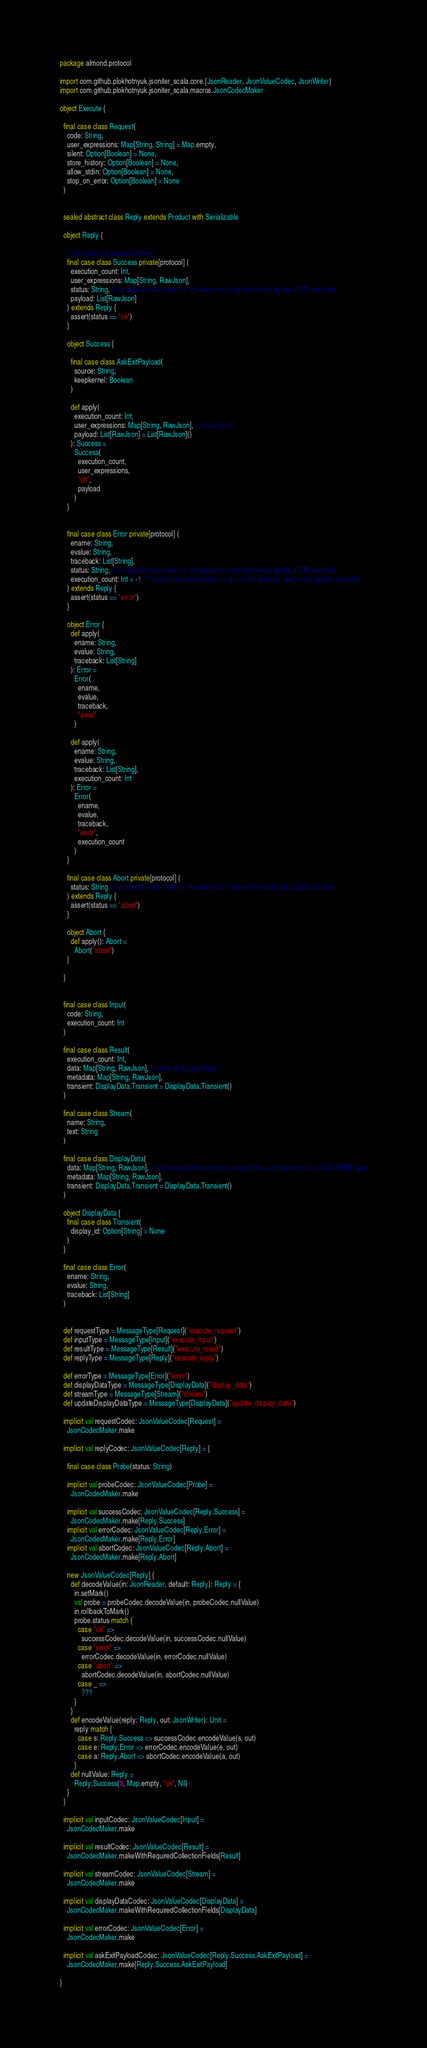<code> <loc_0><loc_0><loc_500><loc_500><_Scala_>package almond.protocol

import com.github.plokhotnyuk.jsoniter_scala.core.{JsonReader, JsonValueCodec, JsonWriter}
import com.github.plokhotnyuk.jsoniter_scala.macros.JsonCodecMaker

object Execute {

  final case class Request(
    code: String,
    user_expressions: Map[String, String] = Map.empty,
    silent: Option[Boolean] = None,
    store_history: Option[Boolean] = None,
    allow_stdin: Option[Boolean] = None,
    stop_on_error: Option[Boolean] = None
  )


  sealed abstract class Reply extends Product with Serializable

  object Reply {

    // payloads not supported here
    final case class Success private[protocol] (
      execution_count: Int,
      user_expressions: Map[String, RawJson],
      status: String, // no default value here for the value not to be swallowed by the JSON encoder
      payload: List[RawJson]
    ) extends Reply {
      assert(status == "ok")
    }

    object Success {

      final case class AskExitPayload(
        source: String,
        keepkernel: Boolean
      )

      def apply(
        execution_count: Int,
        user_expressions: Map[String, RawJson], // value type?
        payload: List[RawJson] = List[RawJson]()
      ): Success =
        Success(
          execution_count,
          user_expressions,
          "ok",
          payload
        )
    }


    final case class Error private[protocol] (
      ename: String,
      evalue: String,
      traceback: List[String],
      status: String, // no default value here for the value not to be swallowed by the JSON encoder
      execution_count: Int = -1 // required in some context (e.g. errored execute_reply from jupyter console)
    ) extends Reply {
      assert(status == "error")
    }

    object Error {
      def apply(
        ename: String,
        evalue: String,
        traceback: List[String]
      ): Error =
        Error(
          ename,
          evalue,
          traceback,
          "error"
        )

      def apply(
        ename: String,
        evalue: String,
        traceback: List[String],
        execution_count: Int
      ): Error =
        Error(
          ename,
          evalue,
          traceback,
          "error",
          execution_count
        )
    }

    final case class Abort private[protocol] (
      status: String // no default value here for the value not to be swallowed by the JSON encoder
    ) extends Reply {
      assert(status == "abort")
    }

    object Abort {
      def apply(): Abort =
        Abort("abort")
    }

  }


  final case class Input(
    code: String,
    execution_count: Int
  )

  final case class Result(
    execution_count: Int,
    data: Map[String, RawJson], // same as DisplayData
    metadata: Map[String, RawJson],
    transient: DisplayData.Transient = DisplayData.Transient()
  )

  final case class Stream(
    name: String,
    text: String
  )

  final case class DisplayData(
    data: Map[String, RawJson], // values are always strings, except if key corresponds to a JSON MIME type
    metadata: Map[String, RawJson],
    transient: DisplayData.Transient = DisplayData.Transient()
  )

  object DisplayData {
    final case class Transient(
      display_id: Option[String] = None
    )
  }

  final case class Error(
    ename: String,
    evalue: String,
    traceback: List[String]
  )


  def requestType = MessageType[Request]("execute_request")
  def inputType = MessageType[Input]("execute_input")
  def resultType = MessageType[Result]("execute_result")
  def replyType = MessageType[Reply]("execute_reply")

  def errorType = MessageType[Error]("error")
  def displayDataType = MessageType[DisplayData]("display_data")
  def streamType = MessageType[Stream]("stream")
  def updateDisplayDataType = MessageType[DisplayData]("update_display_data")

  implicit val requestCodec: JsonValueCodec[Request] =
    JsonCodecMaker.make

  implicit val replyCodec: JsonValueCodec[Reply] = {

    final case class Probe(status: String)

    implicit val probeCodec: JsonValueCodec[Probe] =
      JsonCodecMaker.make

    implicit val successCodec: JsonValueCodec[Reply.Success] =
      JsonCodecMaker.make[Reply.Success]
    implicit val errorCodec: JsonValueCodec[Reply.Error] =
      JsonCodecMaker.make[Reply.Error]
    implicit val abortCodec: JsonValueCodec[Reply.Abort] =
      JsonCodecMaker.make[Reply.Abort]

    new JsonValueCodec[Reply] {
      def decodeValue(in: JsonReader, default: Reply): Reply = {
        in.setMark()
        val probe = probeCodec.decodeValue(in, probeCodec.nullValue)
        in.rollbackToMark()
        probe.status match {
          case "ok" =>
            successCodec.decodeValue(in, successCodec.nullValue)
          case "error" =>
            errorCodec.decodeValue(in, errorCodec.nullValue)
          case "abort" =>
            abortCodec.decodeValue(in, abortCodec.nullValue)
          case _ =>
            ???
        }
      }
      def encodeValue(reply: Reply, out: JsonWriter): Unit =
        reply match {
          case s: Reply.Success => successCodec.encodeValue(s, out)
          case e: Reply.Error => errorCodec.encodeValue(e, out)
          case a: Reply.Abort => abortCodec.encodeValue(a, out)
        }
      def nullValue: Reply =
        Reply.Success(0, Map.empty, "ok", Nil)
    }
  }

  implicit val inputCodec: JsonValueCodec[Input] =
    JsonCodecMaker.make

  implicit val resultCodec: JsonValueCodec[Result] =
    JsonCodecMaker.makeWithRequiredCollectionFields[Result]

  implicit val streamCodec: JsonValueCodec[Stream] =
    JsonCodecMaker.make

  implicit val displayDataCodec: JsonValueCodec[DisplayData] =
    JsonCodecMaker.makeWithRequiredCollectionFields[DisplayData]

  implicit val errorCodec: JsonValueCodec[Error] =
    JsonCodecMaker.make

  implicit val askExitPayloadCodec: JsonValueCodec[Reply.Success.AskExitPayload] =
    JsonCodecMaker.make[Reply.Success.AskExitPayload]

}
</code> 